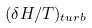Convert formula to latex. <formula><loc_0><loc_0><loc_500><loc_500>( \delta H / T ) _ { t u r b }</formula> 